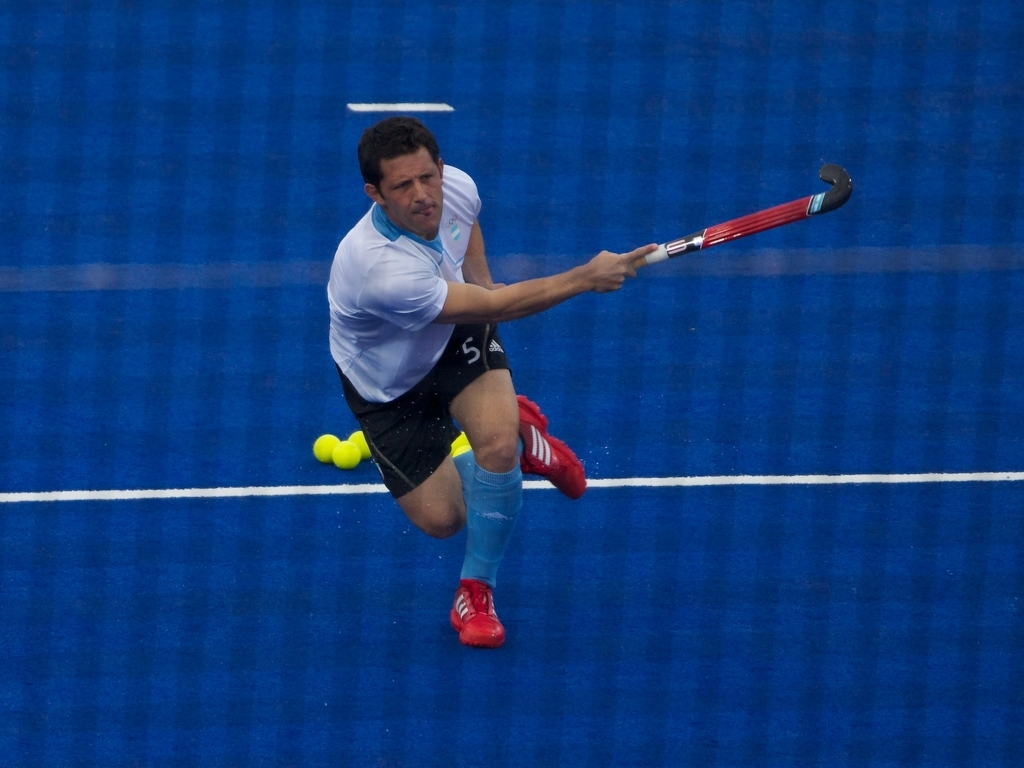Can you tell me what sport is being played in this image? The sport being played in the image is field hockey, which is evident from the player’s uniform, the hockey stick, and the small, hard ball. What does the player's posture and positioning suggest about the moment captured in the image? The player's posture, with his leg lifted and the hockey stick mid-swing, suggests that he is either about to hit the ball or has just hit it. His concentration and body language indicate a dynamic and pivotal moment in the game. 